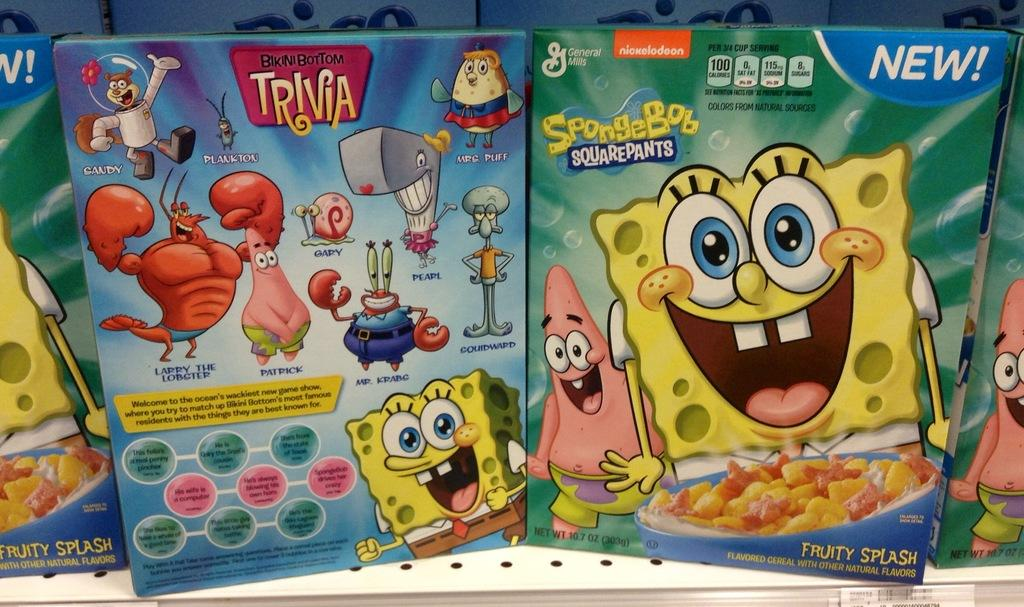What objects are present in the image? There are boxes in the image. What is depicted on the boxes? There are cartoon characters on the boxes. What else can be seen on the boxes? There is writing on the boxes. What type of island is visible in the image? There is no island present in the image; it features boxes with cartoon characters and writing. What is the purpose of the stocking in the image? There is no stocking present in the image. 